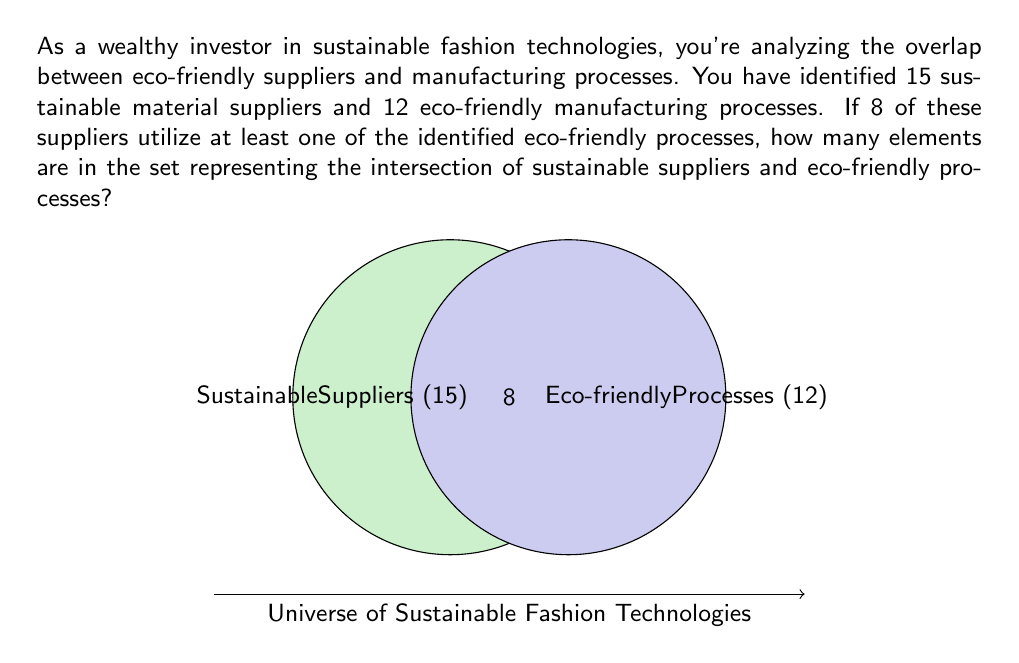Give your solution to this math problem. Let's approach this step-by-step using set theory:

1) Let $S$ be the set of sustainable material suppliers, and $P$ be the set of eco-friendly manufacturing processes.

2) We're given:
   $|S| = 15$ (cardinality of set S)
   $|P| = 12$ (cardinality of set P)

3) We're told that 8 suppliers utilize at least one eco-friendly process. This means:
   $|S \cap P| = 8$

4) The question is asking for the number of elements in the intersection of S and P, which we've just identified as 8.

5) In set theory notation, we can express this as:
   $$|S \cap P| = 8$$

This result represents the number of sustainable suppliers that also use eco-friendly processes, or equivalently, the number of eco-friendly processes that are used by sustainable suppliers.
Answer: 8 